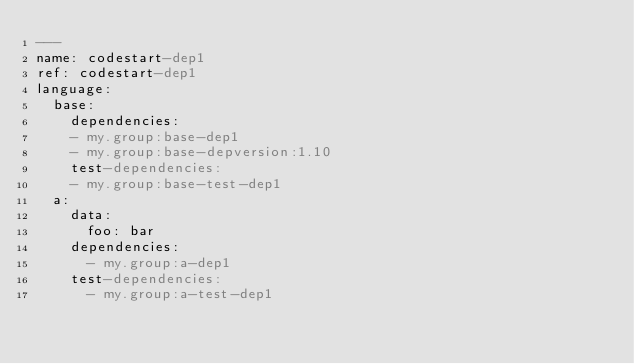Convert code to text. <code><loc_0><loc_0><loc_500><loc_500><_YAML_>---
name: codestart-dep1
ref: codestart-dep1
language:
  base:
    dependencies:
    - my.group:base-dep1
    - my.group:base-depversion:1.10
    test-dependencies:
    - my.group:base-test-dep1
  a:
    data:
      foo: bar
    dependencies:
      - my.group:a-dep1
    test-dependencies:
      - my.group:a-test-dep1</code> 